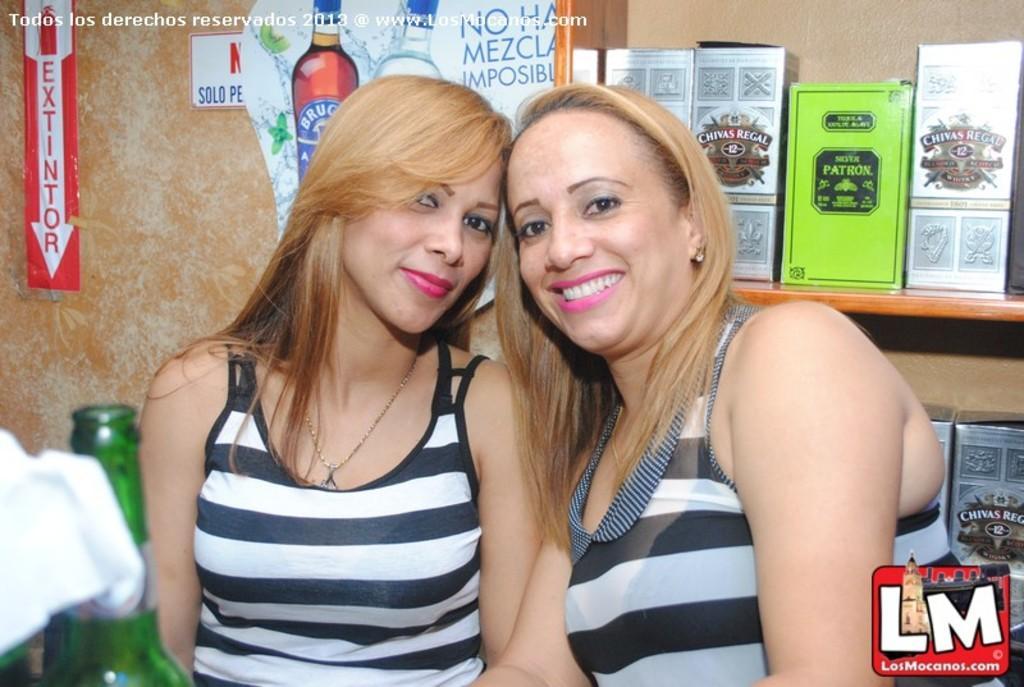In one or two sentences, can you explain what this image depicts? In this image i can see 2 woman next to each other and a bottle. In the background i can see a wall, a poster and few boxes. 